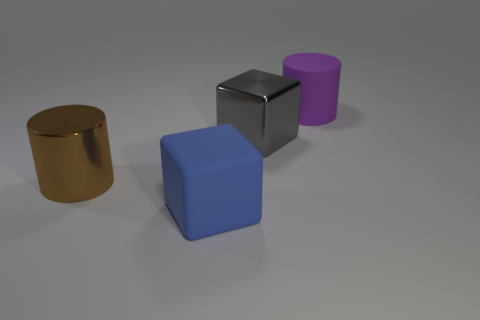Add 4 gray metal objects. How many objects exist? 8 Subtract all blue blocks. How many blocks are left? 1 Subtract 1 blocks. How many blocks are left? 1 Subtract all large matte cylinders. Subtract all large purple things. How many objects are left? 2 Add 1 large gray blocks. How many large gray blocks are left? 2 Add 3 yellow metallic things. How many yellow metallic things exist? 3 Subtract 1 gray cubes. How many objects are left? 3 Subtract all green cubes. Subtract all cyan balls. How many cubes are left? 2 Subtract all yellow blocks. How many red cylinders are left? 0 